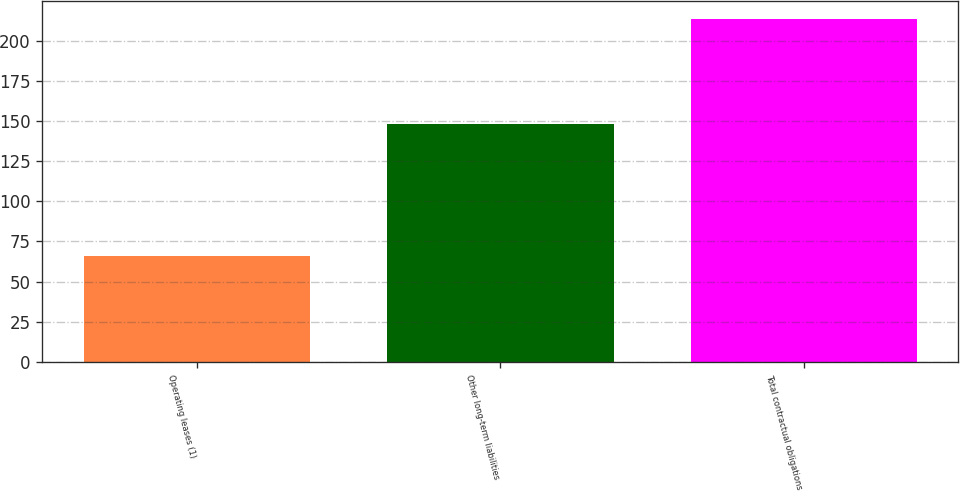<chart> <loc_0><loc_0><loc_500><loc_500><bar_chart><fcel>Operating leases (1)<fcel>Other long-term liabilities<fcel>Total contractual obligations<nl><fcel>65.9<fcel>148.2<fcel>214.1<nl></chart> 